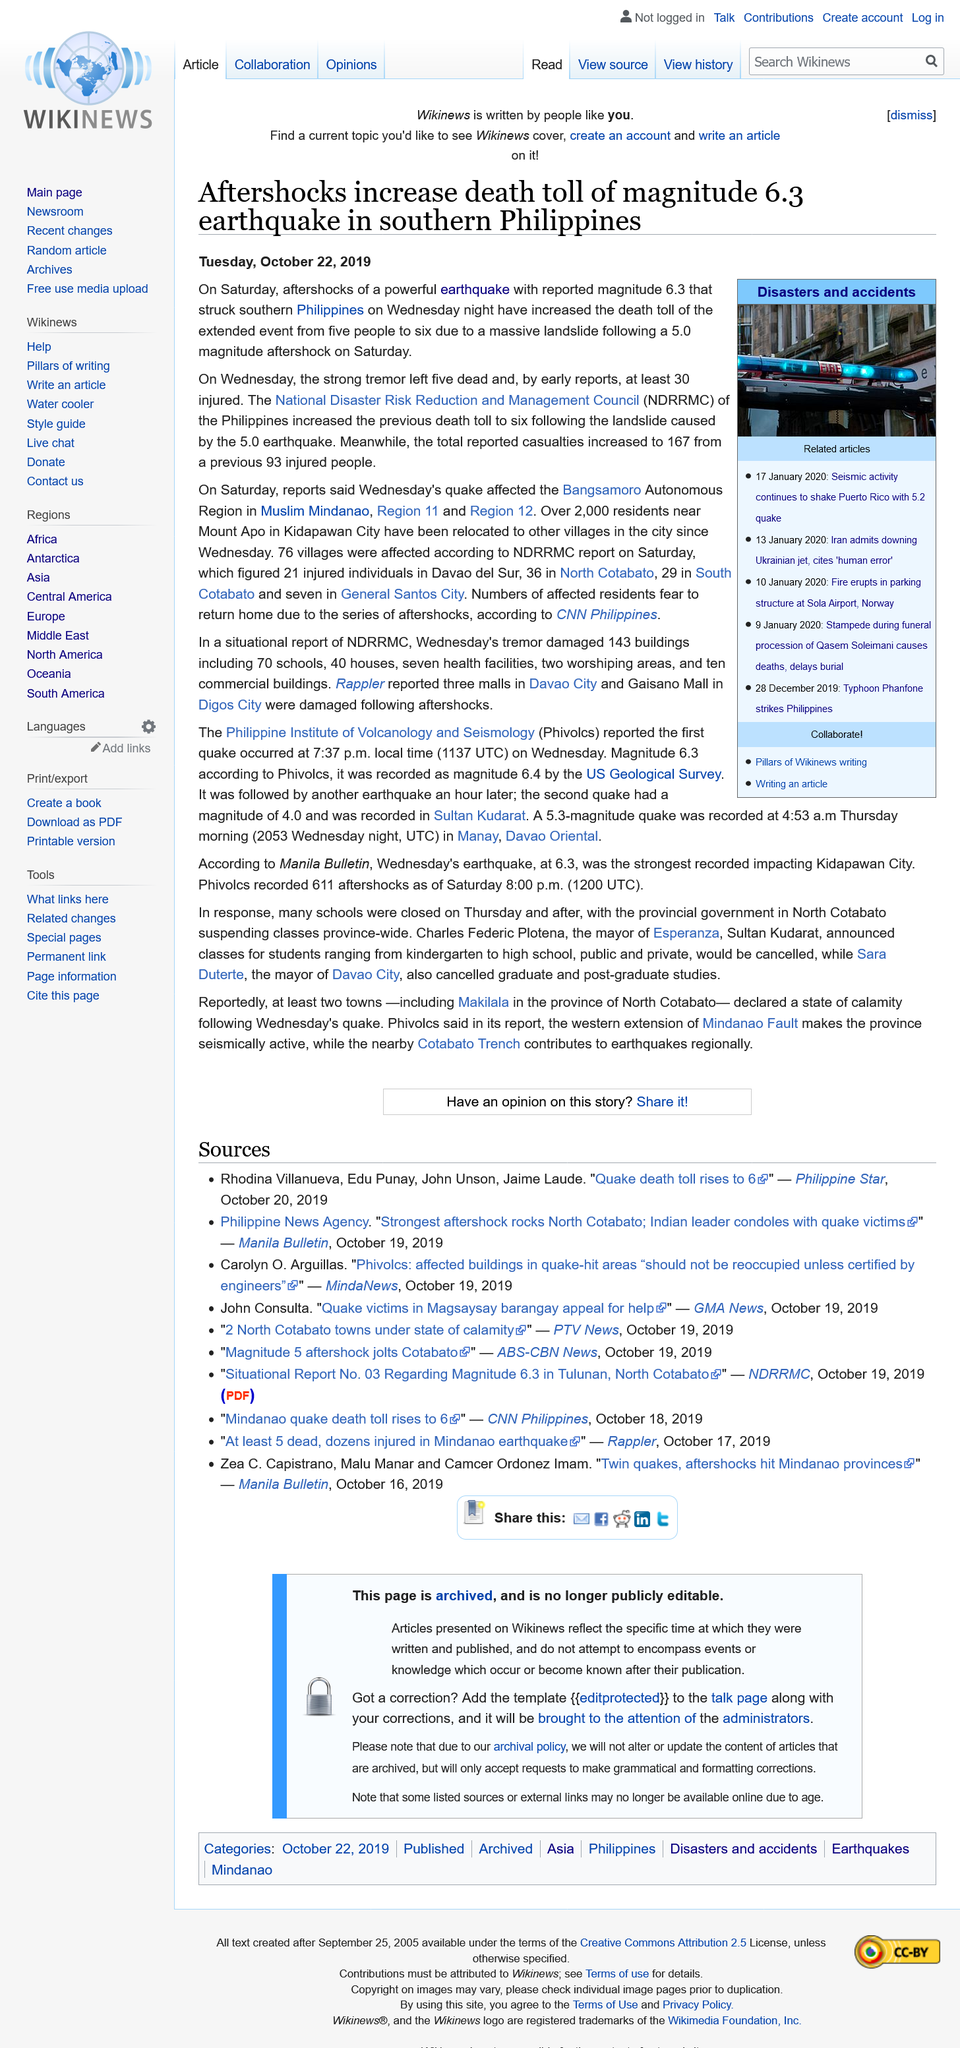Highlight a few significant elements in this photo. The magnitude of the aftershock was 5.0. The death toll rose by one following the aftershock, increasing from 5 to 6. A total of 167 casualties were reported. 